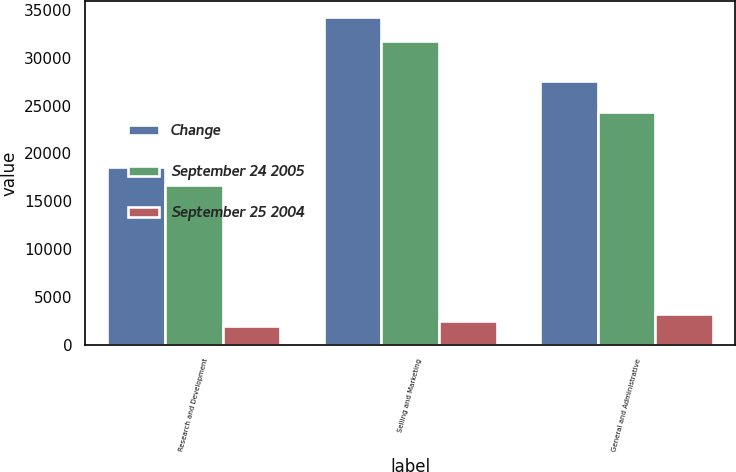Convert chart. <chart><loc_0><loc_0><loc_500><loc_500><stacked_bar_chart><ecel><fcel>Research and Development<fcel>Selling and Marketing<fcel>General and Administrative<nl><fcel>Change<fcel>18617<fcel>34199<fcel>27578<nl><fcel>September 24 2005<fcel>16659<fcel>31761<fcel>24363<nl><fcel>September 25 2004<fcel>1958<fcel>2438<fcel>3215<nl></chart> 